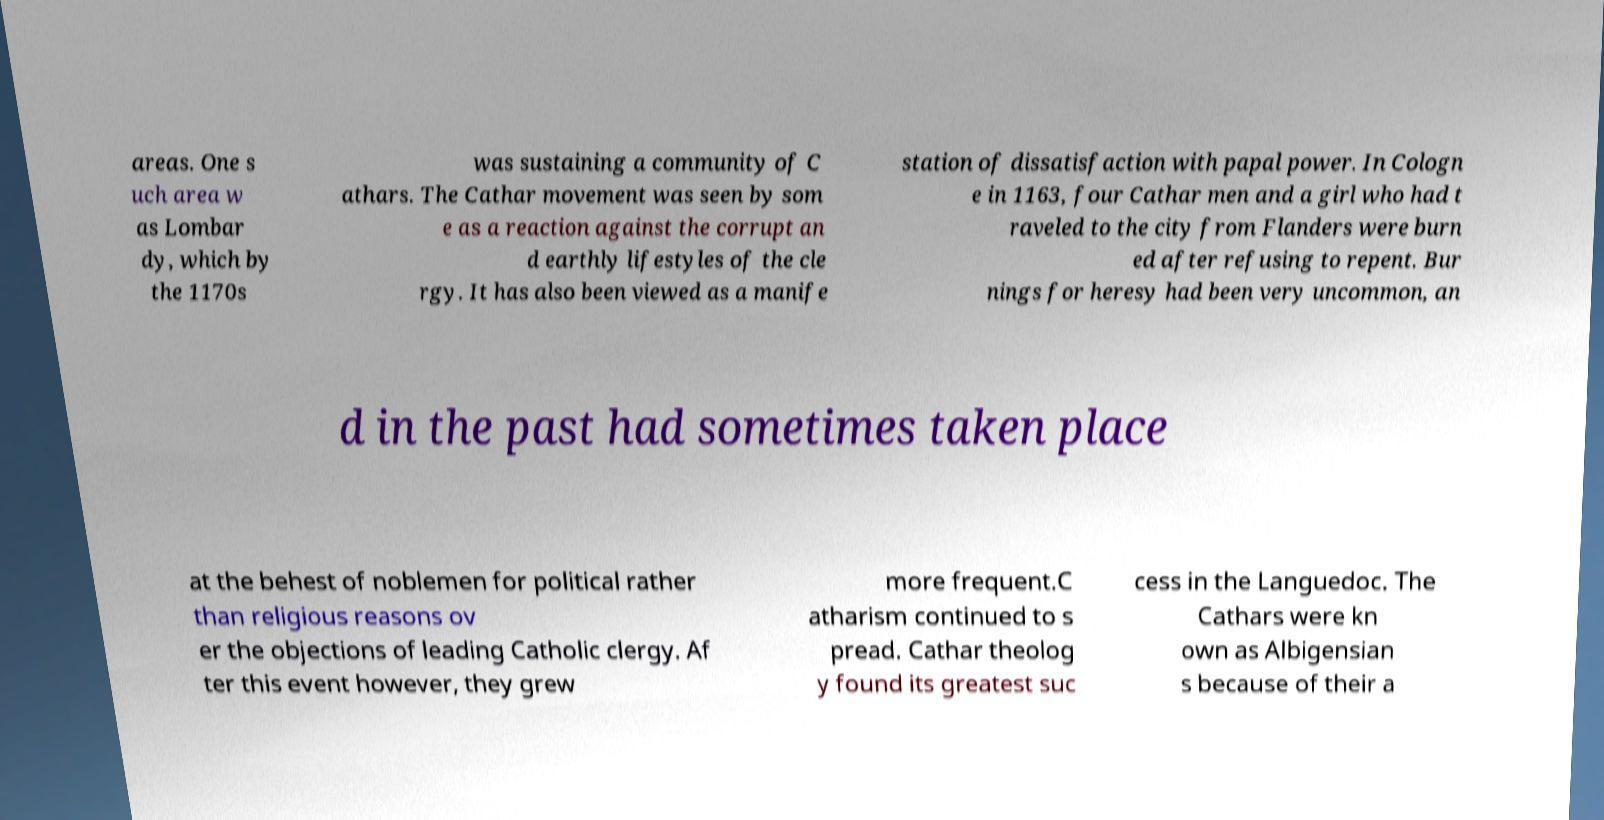Can you read and provide the text displayed in the image?This photo seems to have some interesting text. Can you extract and type it out for me? areas. One s uch area w as Lombar dy, which by the 1170s was sustaining a community of C athars. The Cathar movement was seen by som e as a reaction against the corrupt an d earthly lifestyles of the cle rgy. It has also been viewed as a manife station of dissatisfaction with papal power. In Cologn e in 1163, four Cathar men and a girl who had t raveled to the city from Flanders were burn ed after refusing to repent. Bur nings for heresy had been very uncommon, an d in the past had sometimes taken place at the behest of noblemen for political rather than religious reasons ov er the objections of leading Catholic clergy. Af ter this event however, they grew more frequent.C atharism continued to s pread. Cathar theolog y found its greatest suc cess in the Languedoc. The Cathars were kn own as Albigensian s because of their a 